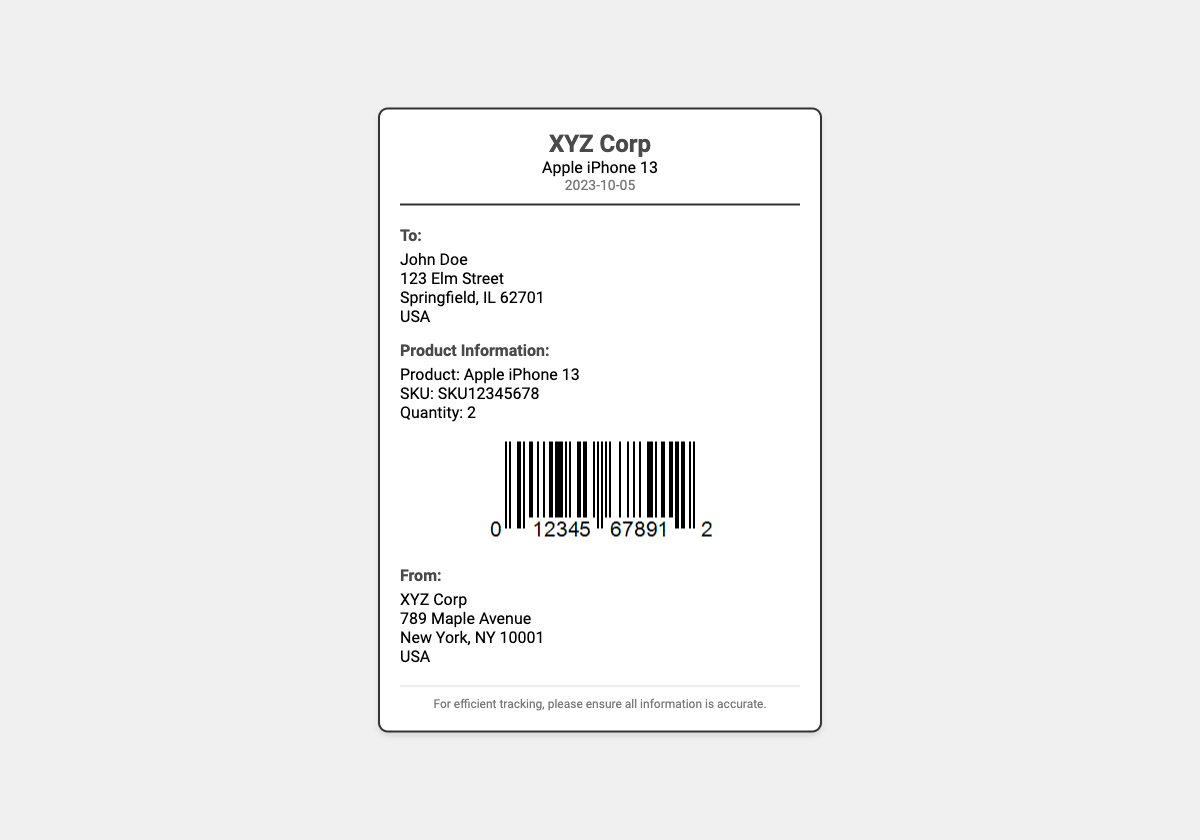What is the product name? The product name is mentioned in the header and product information sections of the document.
Answer: Apple iPhone 13 What is the SKU? The SKU is outlined in the product information section of the label.
Answer: SKU12345678 What date is on the shipping label? The date is specified in the header of the shipping label.
Answer: 2023-10-05 What is the quantity of the product? The quantity is listed under the product information section of the document.
Answer: 2 Who is the recipient of the shipment? The recipient's name is included in the "To" section of the shipping label.
Answer: John Doe Where is the shipping origin? The origin address is provided in the "From" section of the shipping label.
Answer: 789 Maple Avenue What company is the shipping label for? The company name is included in the header and "From" section of the label.
Answer: XYZ Corp What is the purpose of the footer message? The footer message highlights the importance of accurate information for tracking purposes.
Answer: For efficient tracking, please ensure all information is accurate What type of code is displayed on the label? The type of code in the document is indicated under the barcode image.
Answer: Barcode 